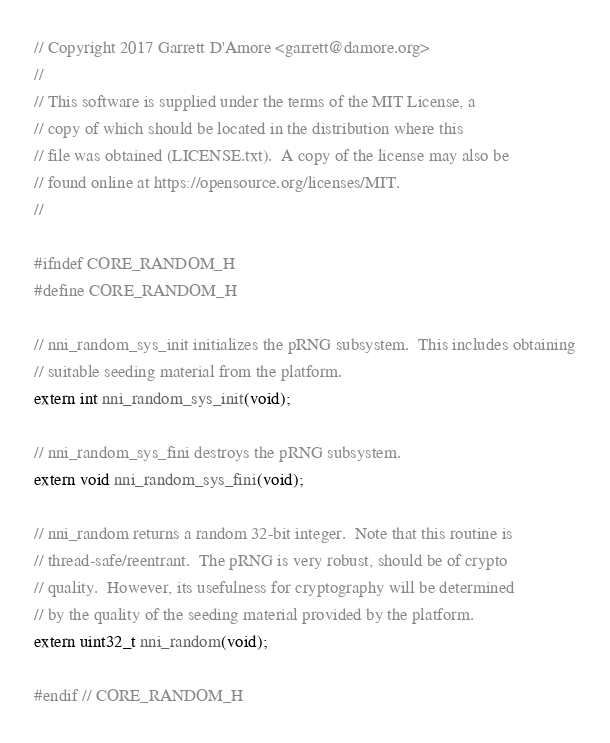<code> <loc_0><loc_0><loc_500><loc_500><_C_>// Copyright 2017 Garrett D'Amore <garrett@damore.org>
//
// This software is supplied under the terms of the MIT License, a
// copy of which should be located in the distribution where this
// file was obtained (LICENSE.txt).  A copy of the license may also be
// found online at https://opensource.org/licenses/MIT.
//

#ifndef CORE_RANDOM_H
#define CORE_RANDOM_H

// nni_random_sys_init initializes the pRNG subsystem.  This includes obtaining
// suitable seeding material from the platform.
extern int nni_random_sys_init(void);

// nni_random_sys_fini destroys the pRNG subsystem.
extern void nni_random_sys_fini(void);

// nni_random returns a random 32-bit integer.  Note that this routine is
// thread-safe/reentrant.  The pRNG is very robust, should be of crypto
// quality.  However, its usefulness for cryptography will be determined
// by the quality of the seeding material provided by the platform.
extern uint32_t nni_random(void);

#endif // CORE_RANDOM_H
</code> 